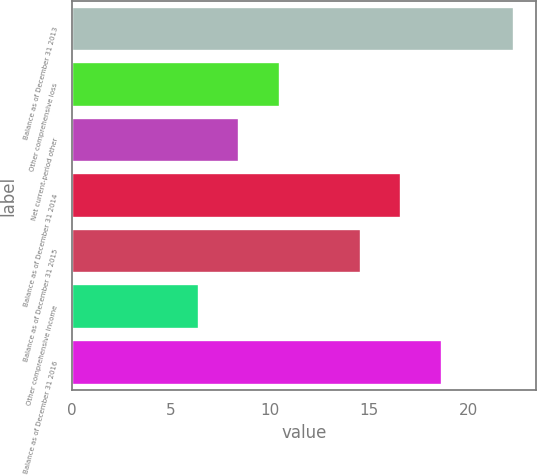Convert chart to OTSL. <chart><loc_0><loc_0><loc_500><loc_500><bar_chart><fcel>Balance as of December 31 2013<fcel>Other comprehensive loss<fcel>Net current-period other<fcel>Balance as of December 31 2014<fcel>Balance as of December 31 2015<fcel>Other comprehensive income<fcel>Balance as of December 31 2016<nl><fcel>22.3<fcel>10.48<fcel>8.44<fcel>16.6<fcel>14.56<fcel>6.4<fcel>18.64<nl></chart> 